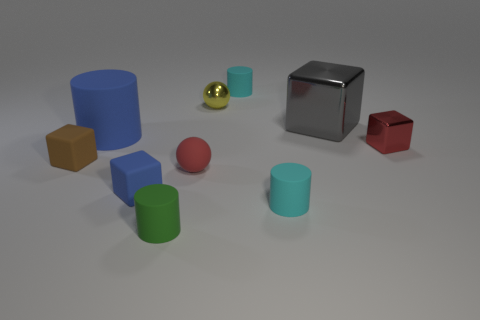What number of gray objects are either metallic things or small matte objects?
Provide a succinct answer. 1. There is a tiny red metal block that is on the right side of the big shiny block behind the tiny blue object; is there a small yellow metal thing in front of it?
Provide a short and direct response. No. Is there any other thing that is the same size as the red ball?
Provide a short and direct response. Yes. Is the color of the large matte object the same as the tiny shiny ball?
Make the answer very short. No. There is a matte thing left of the cylinder that is on the left side of the tiny green thing; what color is it?
Make the answer very short. Brown. How many small things are either brown metal blocks or rubber balls?
Offer a very short reply. 1. The object that is in front of the red metal cube and left of the small blue rubber block is what color?
Your response must be concise. Brown. Is the big gray block made of the same material as the large cylinder?
Offer a terse response. No. There is a big gray object; what shape is it?
Give a very brief answer. Cube. What number of small red spheres are in front of the matte cylinder in front of the cyan matte cylinder in front of the tiny red metal object?
Give a very brief answer. 0. 